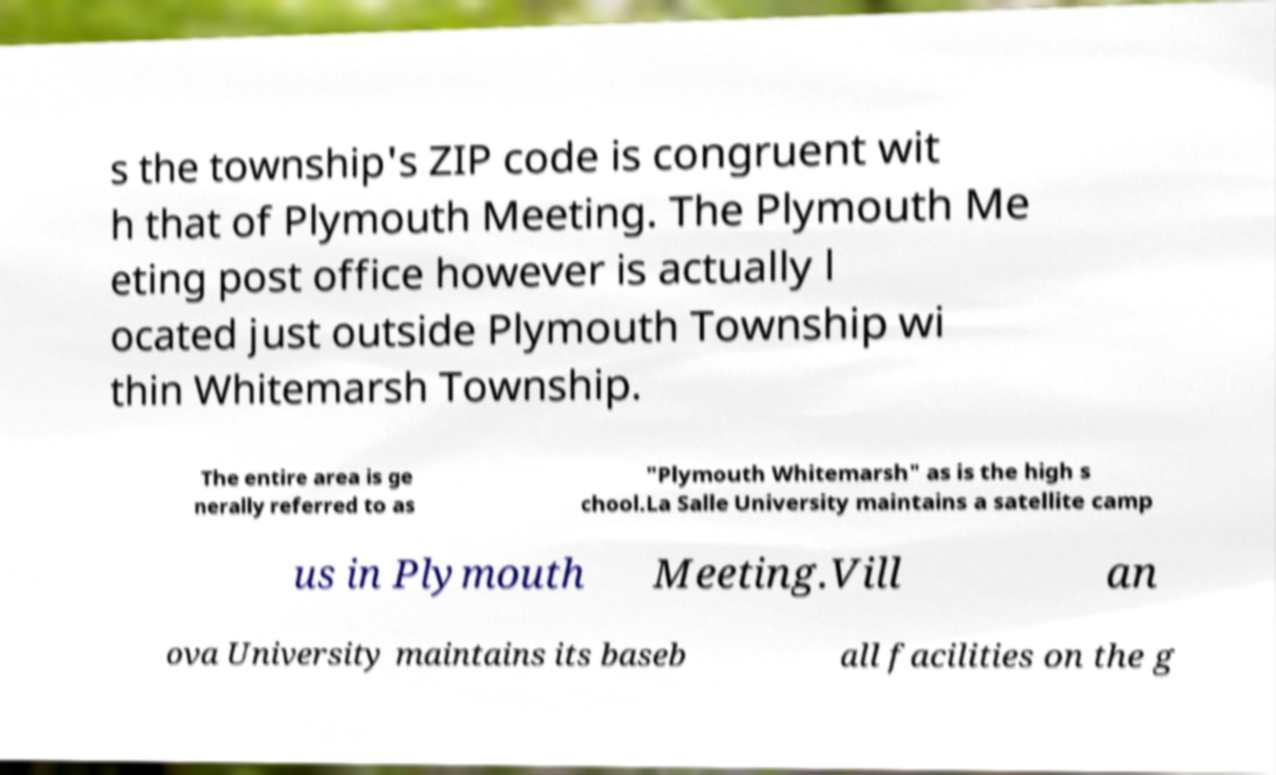What messages or text are displayed in this image? I need them in a readable, typed format. s the township's ZIP code is congruent wit h that of Plymouth Meeting. The Plymouth Me eting post office however is actually l ocated just outside Plymouth Township wi thin Whitemarsh Township. The entire area is ge nerally referred to as "Plymouth Whitemarsh" as is the high s chool.La Salle University maintains a satellite camp us in Plymouth Meeting.Vill an ova University maintains its baseb all facilities on the g 